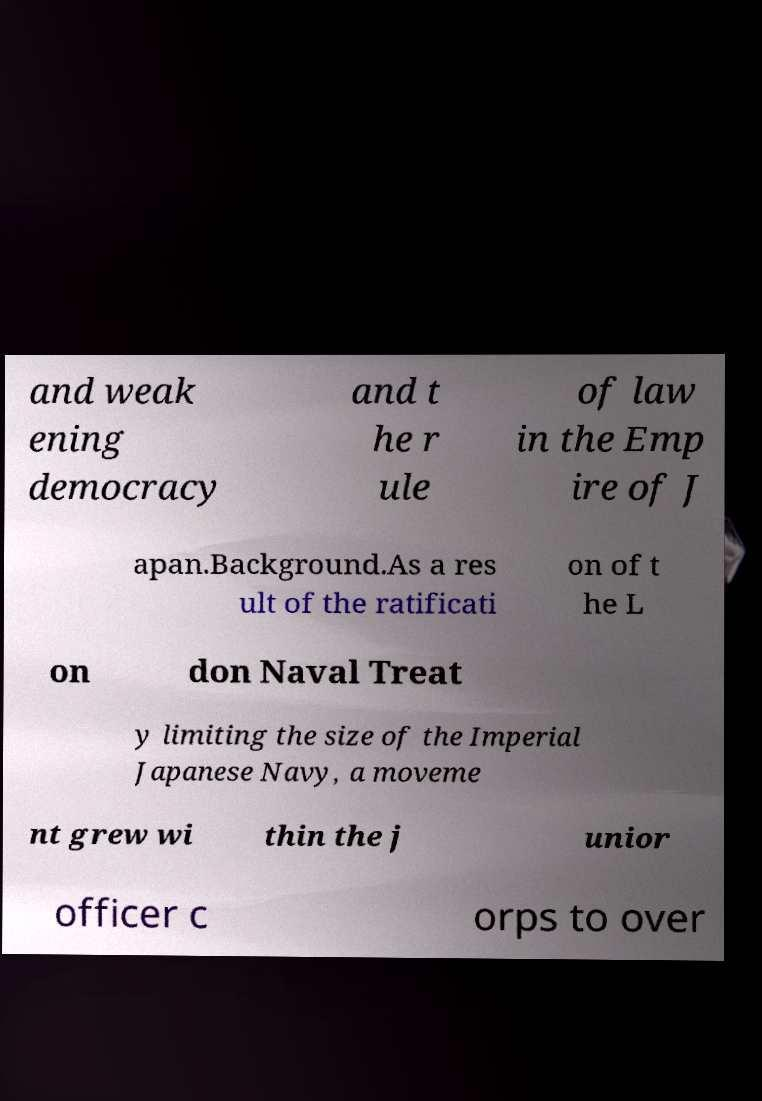For documentation purposes, I need the text within this image transcribed. Could you provide that? and weak ening democracy and t he r ule of law in the Emp ire of J apan.Background.As a res ult of the ratificati on of t he L on don Naval Treat y limiting the size of the Imperial Japanese Navy, a moveme nt grew wi thin the j unior officer c orps to over 